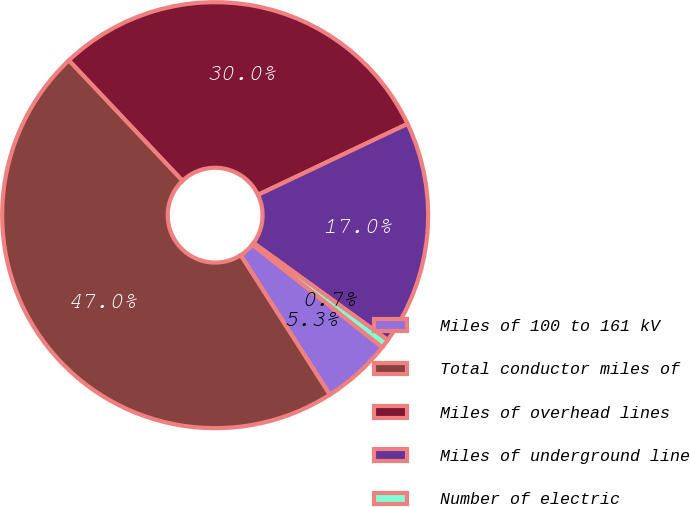<chart> <loc_0><loc_0><loc_500><loc_500><pie_chart><fcel>Miles of 100 to 161 kV<fcel>Total conductor miles of<fcel>Miles of overhead lines<fcel>Miles of underground line<fcel>Number of electric<nl><fcel>5.31%<fcel>47.01%<fcel>29.99%<fcel>17.02%<fcel>0.68%<nl></chart> 